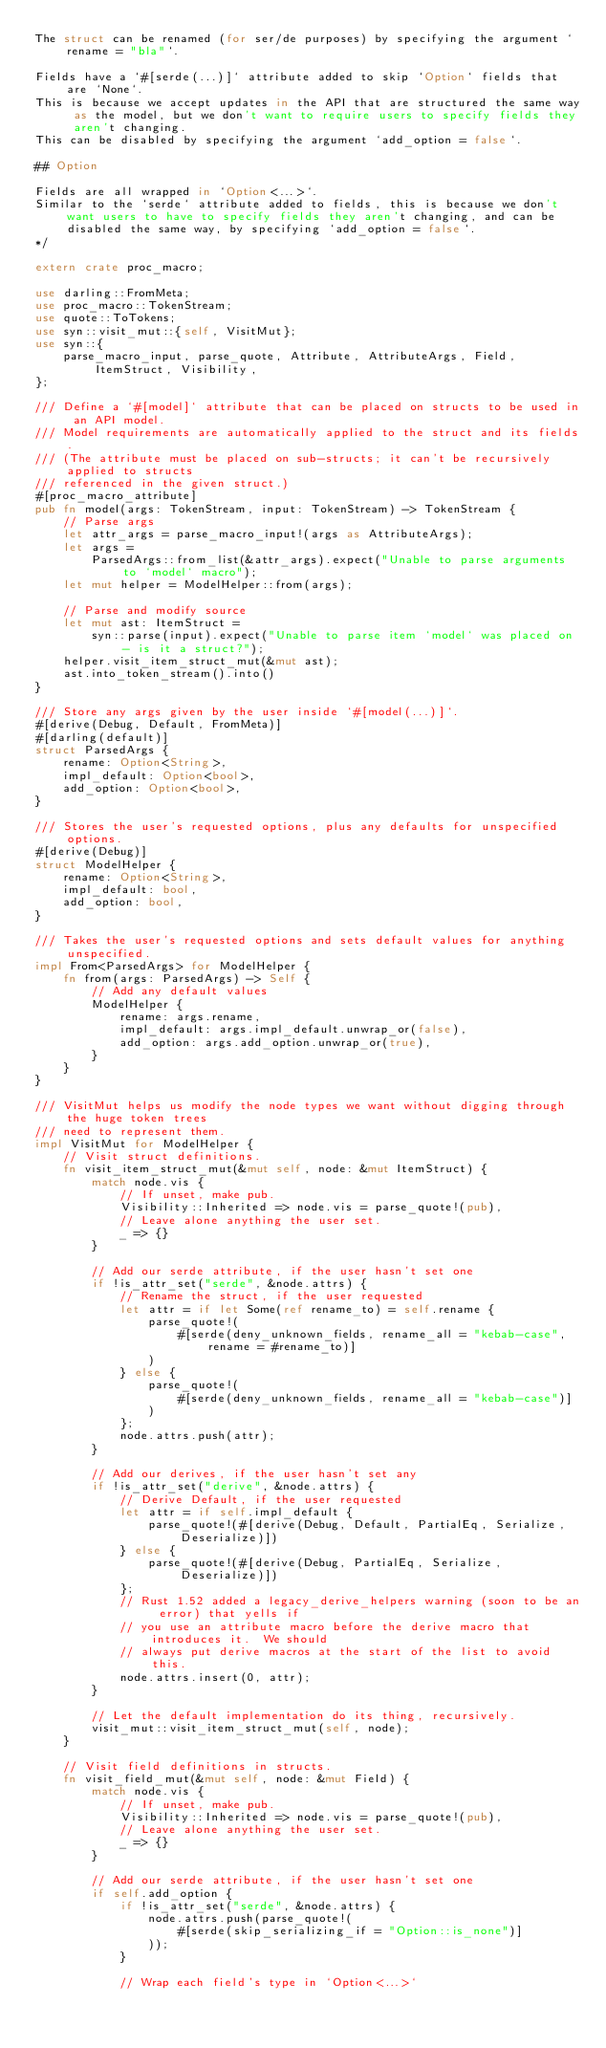<code> <loc_0><loc_0><loc_500><loc_500><_Rust_>The struct can be renamed (for ser/de purposes) by specifying the argument `rename = "bla"`.

Fields have a `#[serde(...)]` attribute added to skip `Option` fields that are `None`.
This is because we accept updates in the API that are structured the same way as the model, but we don't want to require users to specify fields they aren't changing.
This can be disabled by specifying the argument `add_option = false`.

## Option

Fields are all wrapped in `Option<...>`.
Similar to the `serde` attribute added to fields, this is because we don't want users to have to specify fields they aren't changing, and can be disabled the same way, by specifying `add_option = false`.
*/

extern crate proc_macro;

use darling::FromMeta;
use proc_macro::TokenStream;
use quote::ToTokens;
use syn::visit_mut::{self, VisitMut};
use syn::{
    parse_macro_input, parse_quote, Attribute, AttributeArgs, Field, ItemStruct, Visibility,
};

/// Define a `#[model]` attribute that can be placed on structs to be used in an API model.
/// Model requirements are automatically applied to the struct and its fields.
/// (The attribute must be placed on sub-structs; it can't be recursively applied to structs
/// referenced in the given struct.)
#[proc_macro_attribute]
pub fn model(args: TokenStream, input: TokenStream) -> TokenStream {
    // Parse args
    let attr_args = parse_macro_input!(args as AttributeArgs);
    let args =
        ParsedArgs::from_list(&attr_args).expect("Unable to parse arguments to `model` macro");
    let mut helper = ModelHelper::from(args);

    // Parse and modify source
    let mut ast: ItemStruct =
        syn::parse(input).expect("Unable to parse item `model` was placed on - is it a struct?");
    helper.visit_item_struct_mut(&mut ast);
    ast.into_token_stream().into()
}

/// Store any args given by the user inside `#[model(...)]`.
#[derive(Debug, Default, FromMeta)]
#[darling(default)]
struct ParsedArgs {
    rename: Option<String>,
    impl_default: Option<bool>,
    add_option: Option<bool>,
}

/// Stores the user's requested options, plus any defaults for unspecified options.
#[derive(Debug)]
struct ModelHelper {
    rename: Option<String>,
    impl_default: bool,
    add_option: bool,
}

/// Takes the user's requested options and sets default values for anything unspecified.
impl From<ParsedArgs> for ModelHelper {
    fn from(args: ParsedArgs) -> Self {
        // Add any default values
        ModelHelper {
            rename: args.rename,
            impl_default: args.impl_default.unwrap_or(false),
            add_option: args.add_option.unwrap_or(true),
        }
    }
}

/// VisitMut helps us modify the node types we want without digging through the huge token trees
/// need to represent them.
impl VisitMut for ModelHelper {
    // Visit struct definitions.
    fn visit_item_struct_mut(&mut self, node: &mut ItemStruct) {
        match node.vis {
            // If unset, make pub.
            Visibility::Inherited => node.vis = parse_quote!(pub),
            // Leave alone anything the user set.
            _ => {}
        }

        // Add our serde attribute, if the user hasn't set one
        if !is_attr_set("serde", &node.attrs) {
            // Rename the struct, if the user requested
            let attr = if let Some(ref rename_to) = self.rename {
                parse_quote!(
                    #[serde(deny_unknown_fields, rename_all = "kebab-case", rename = #rename_to)]
                )
            } else {
                parse_quote!(
                    #[serde(deny_unknown_fields, rename_all = "kebab-case")]
                )
            };
            node.attrs.push(attr);
        }

        // Add our derives, if the user hasn't set any
        if !is_attr_set("derive", &node.attrs) {
            // Derive Default, if the user requested
            let attr = if self.impl_default {
                parse_quote!(#[derive(Debug, Default, PartialEq, Serialize, Deserialize)])
            } else {
                parse_quote!(#[derive(Debug, PartialEq, Serialize, Deserialize)])
            };
            // Rust 1.52 added a legacy_derive_helpers warning (soon to be an error) that yells if
            // you use an attribute macro before the derive macro that introduces it.  We should
            // always put derive macros at the start of the list to avoid this.
            node.attrs.insert(0, attr);
        }

        // Let the default implementation do its thing, recursively.
        visit_mut::visit_item_struct_mut(self, node);
    }

    // Visit field definitions in structs.
    fn visit_field_mut(&mut self, node: &mut Field) {
        match node.vis {
            // If unset, make pub.
            Visibility::Inherited => node.vis = parse_quote!(pub),
            // Leave alone anything the user set.
            _ => {}
        }

        // Add our serde attribute, if the user hasn't set one
        if self.add_option {
            if !is_attr_set("serde", &node.attrs) {
                node.attrs.push(parse_quote!(
                    #[serde(skip_serializing_if = "Option::is_none")]
                ));
            }

            // Wrap each field's type in `Option<...>`</code> 